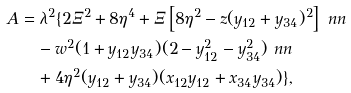Convert formula to latex. <formula><loc_0><loc_0><loc_500><loc_500>A & = \lambda ^ { 2 } \{ 2 \Xi ^ { 2 } + 8 \eta ^ { 4 } + \Xi \left [ 8 \eta ^ { 2 } - z ( y _ { 1 2 } + y _ { 3 4 } ) ^ { 2 } \right ] \ n n \\ & \quad - w ^ { 2 } ( 1 + y _ { 1 2 } y _ { 3 4 } ) ( 2 - y _ { 1 2 } ^ { 2 } - y _ { 3 4 } ^ { 2 } ) \ n n \\ & \quad + 4 \eta ^ { 2 } ( y _ { 1 2 } + y _ { 3 4 } ) ( x _ { 1 2 } y _ { 1 2 } + x _ { 3 4 } y _ { 3 4 } ) \} ,</formula> 